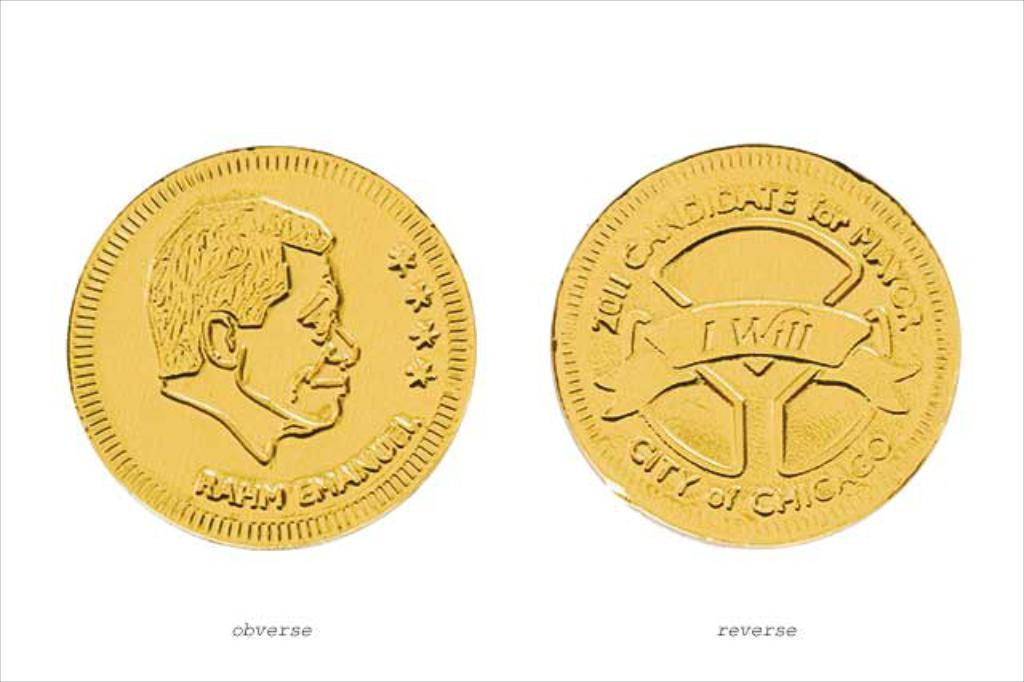Provide a one-sentence caption for the provided image. A coin for the 2011 candidate for mayor of Chicago has four stars on the front side. 